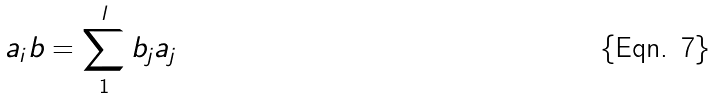Convert formula to latex. <formula><loc_0><loc_0><loc_500><loc_500>a _ { i } b = \sum _ { 1 } ^ { l } b _ { j } a _ { j }</formula> 